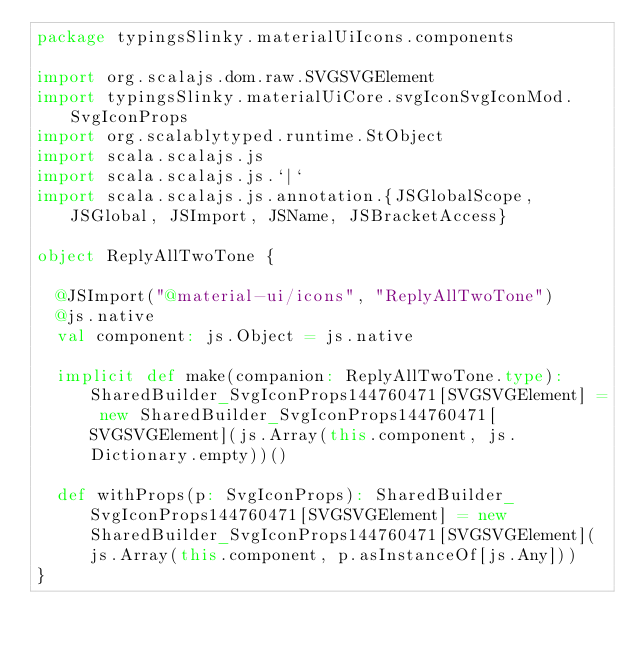<code> <loc_0><loc_0><loc_500><loc_500><_Scala_>package typingsSlinky.materialUiIcons.components

import org.scalajs.dom.raw.SVGSVGElement
import typingsSlinky.materialUiCore.svgIconSvgIconMod.SvgIconProps
import org.scalablytyped.runtime.StObject
import scala.scalajs.js
import scala.scalajs.js.`|`
import scala.scalajs.js.annotation.{JSGlobalScope, JSGlobal, JSImport, JSName, JSBracketAccess}

object ReplyAllTwoTone {
  
  @JSImport("@material-ui/icons", "ReplyAllTwoTone")
  @js.native
  val component: js.Object = js.native
  
  implicit def make(companion: ReplyAllTwoTone.type): SharedBuilder_SvgIconProps144760471[SVGSVGElement] = new SharedBuilder_SvgIconProps144760471[SVGSVGElement](js.Array(this.component, js.Dictionary.empty))()
  
  def withProps(p: SvgIconProps): SharedBuilder_SvgIconProps144760471[SVGSVGElement] = new SharedBuilder_SvgIconProps144760471[SVGSVGElement](js.Array(this.component, p.asInstanceOf[js.Any]))
}
</code> 